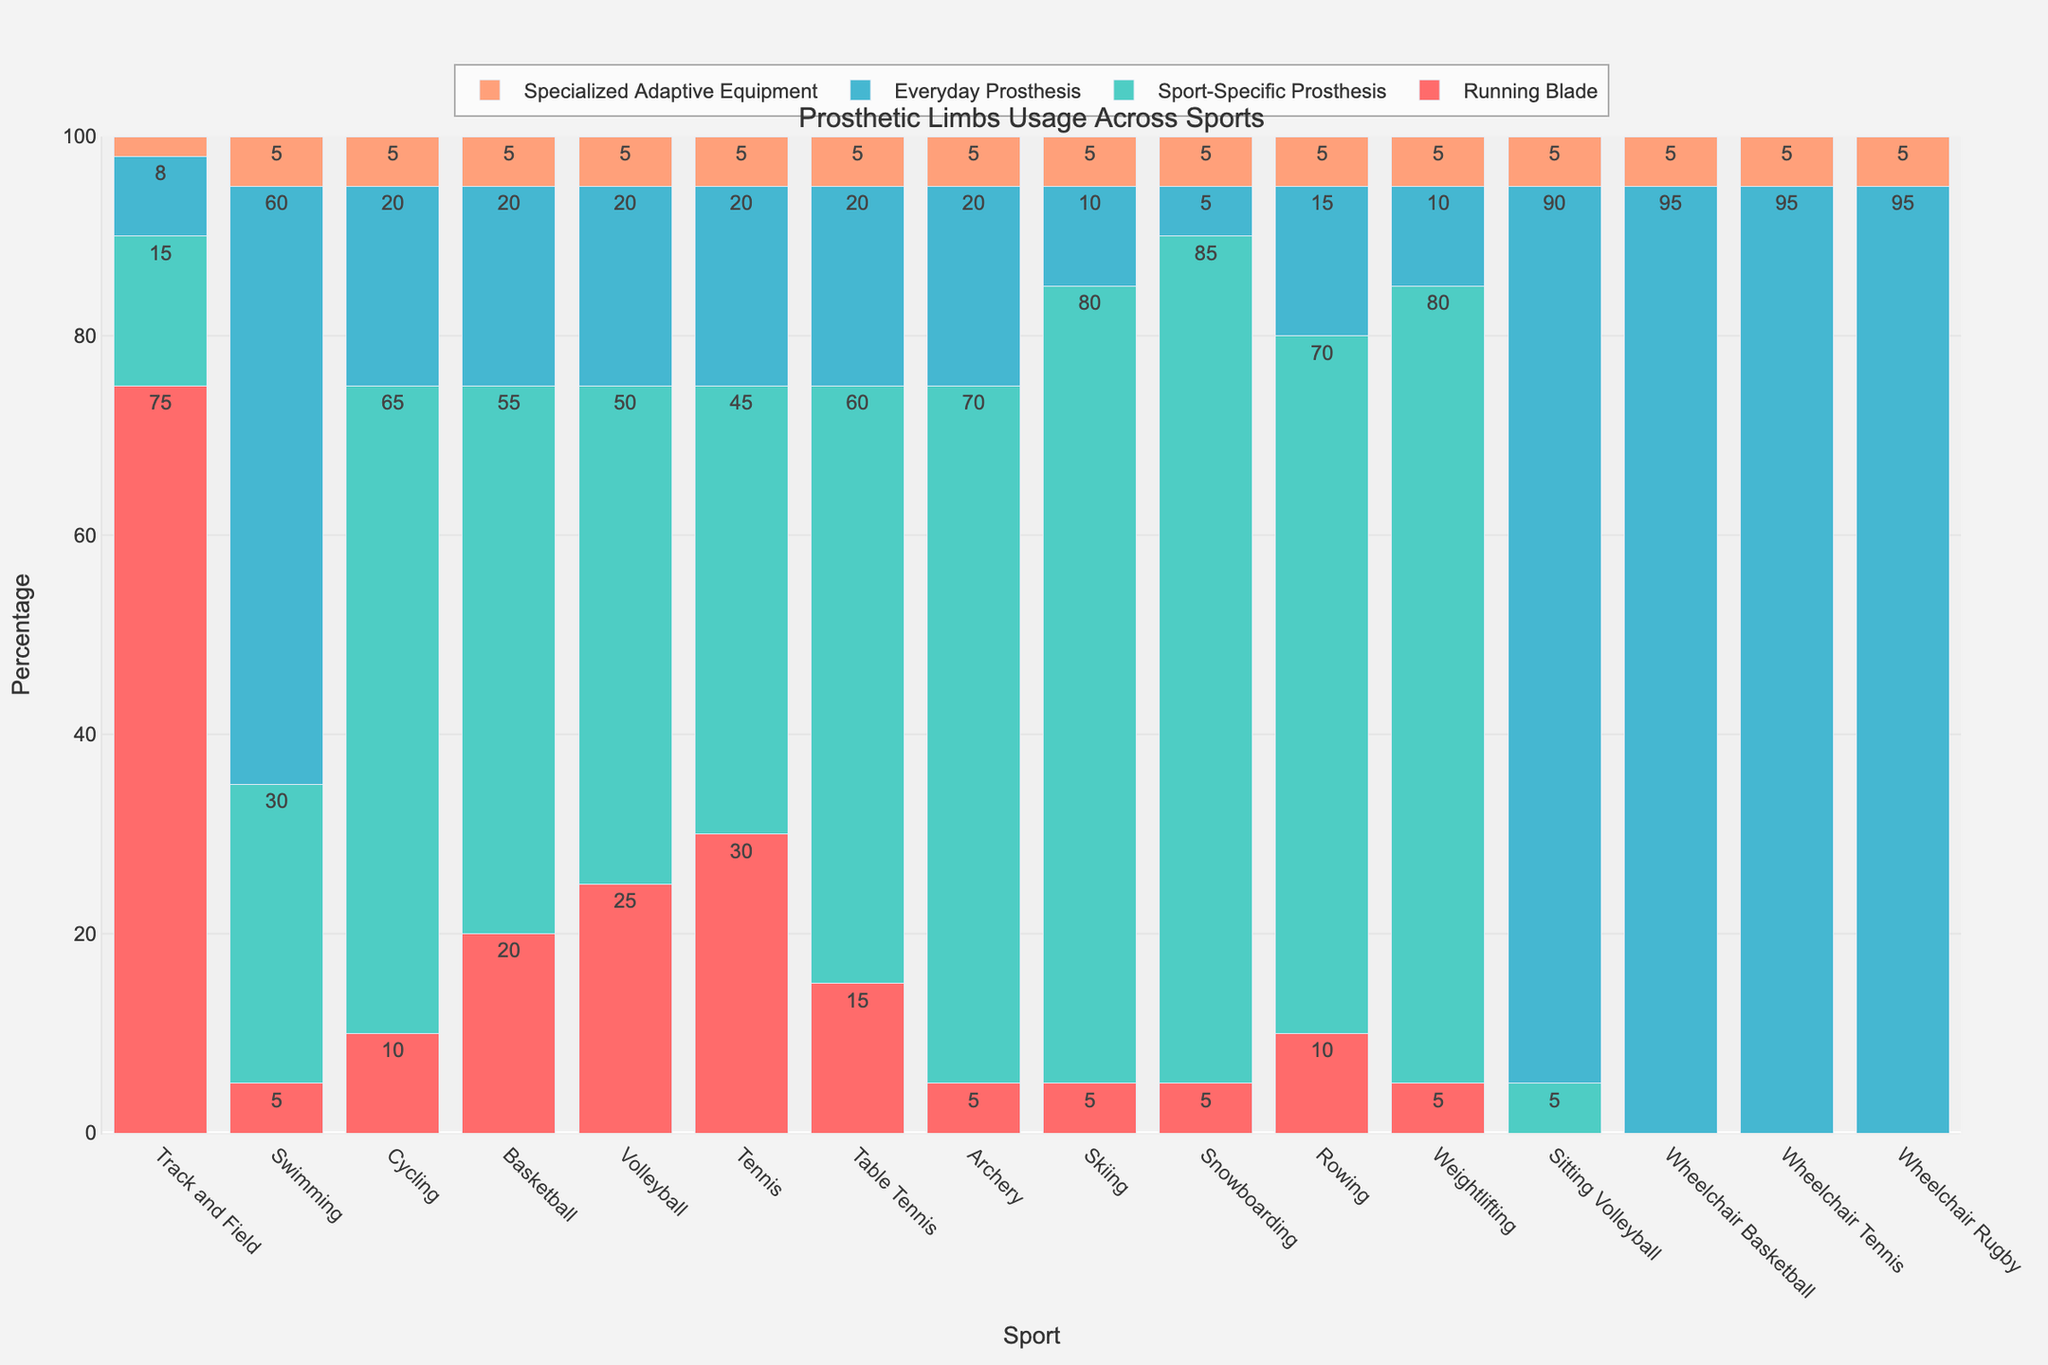Which sport has the highest usage of Everyday Prosthesis? According to the bar chart, Wheelchair Basketball, Wheelchair Tennis, and Wheelchair Rugby all have the highest usage of Everyday Prosthesis with 95%.
Answer: Wheelchair Basketball, Wheelchair Tennis, and Wheelchair Rugby Which sport uses the Running Blade prosthetic the most? Observing the bar chart, Track and Field shows the highest usage of Running Blade with 75%.
Answer: Track and Field What's the combined percentage for Sport-Specific Prosthesis and Specialized Adaptive Equipment in Swimming? The percentage of Sport-Specific Prosthesis in Swimming is 30% and that of Specialized Adaptive Equipment is 5%. Adding these together, 30 + 5 = 35%.
Answer: 35% Which sports have 60% or more of their athletes using Sport-Specific Prosthesis? Looking at the bar chart, the sports with Sport-Specific Prosthesis usage of 60% or above are Table Tennis, Archery, Skiing, Snowboarding, and Weightlifting.
Answer: Table Tennis, Archery, Skiing, Snowboarding, and Weightlifting Which sport has the lowest combined percentage for Running Blade and Sport-Specific Prosthesis? Combining Running Blade and Sport-Specific Prosthesis, Swimming has the lowest percentages: 5% (Running Blade) + 30% (Sport-Specific Prosthesis) = 35%.
Answer: Swimming What is the most frequently used type of prosthesis in Tennis? The bar chart shows Sport-Specific Prosthesis being the most used type in Tennis with 45%.
Answer: Sport-Specific Prosthesis Compare the usage of Specialized Adaptive Equipment across all sports. Which sport uses it the least and the most? Observing the chart, all sports seem to have an equal usage of Specialized Adaptive Equipment at 5%, except Track and Field where it's used 2%.
Answer: Least: Track and Field, Most: All other sports (5%) How does the percentage usage of Everyday Prosthesis in Skiing compare to that in Snowboarding? According to the bar chart, Skiing has 10% usage of Everyday Prosthesis, whereas Snowboarding has only 5%.
Answer: Skiing: 10%, Snowboarding: 5% In which sport is the balance of different types of prosthetics most evenly distributed? Examining the bar chart, Track and Field has the most even distribution among Running Blade (75%), Sport-Specific Prosthesis (15%), Everyday Prosthesis (8%), and Specialized Adaptive Equipment (2%).
Answer: Track and Field What proportion of Cycling athletes use Everyday Prosthesis compared to Specialized Adaptive Equipment? From the bar chart, Cycling has 20% using Everyday Prosthesis and 5% using Specialized Adaptive Equipment. Therefore, 20/5 = 4 times more athletes use Everyday Prosthesis compared to Specialized Adaptive Equipment.
Answer: 4 times more 